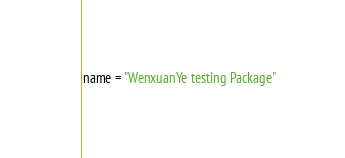<code> <loc_0><loc_0><loc_500><loc_500><_Python_>name = "WenxuanYe testing Package"</code> 